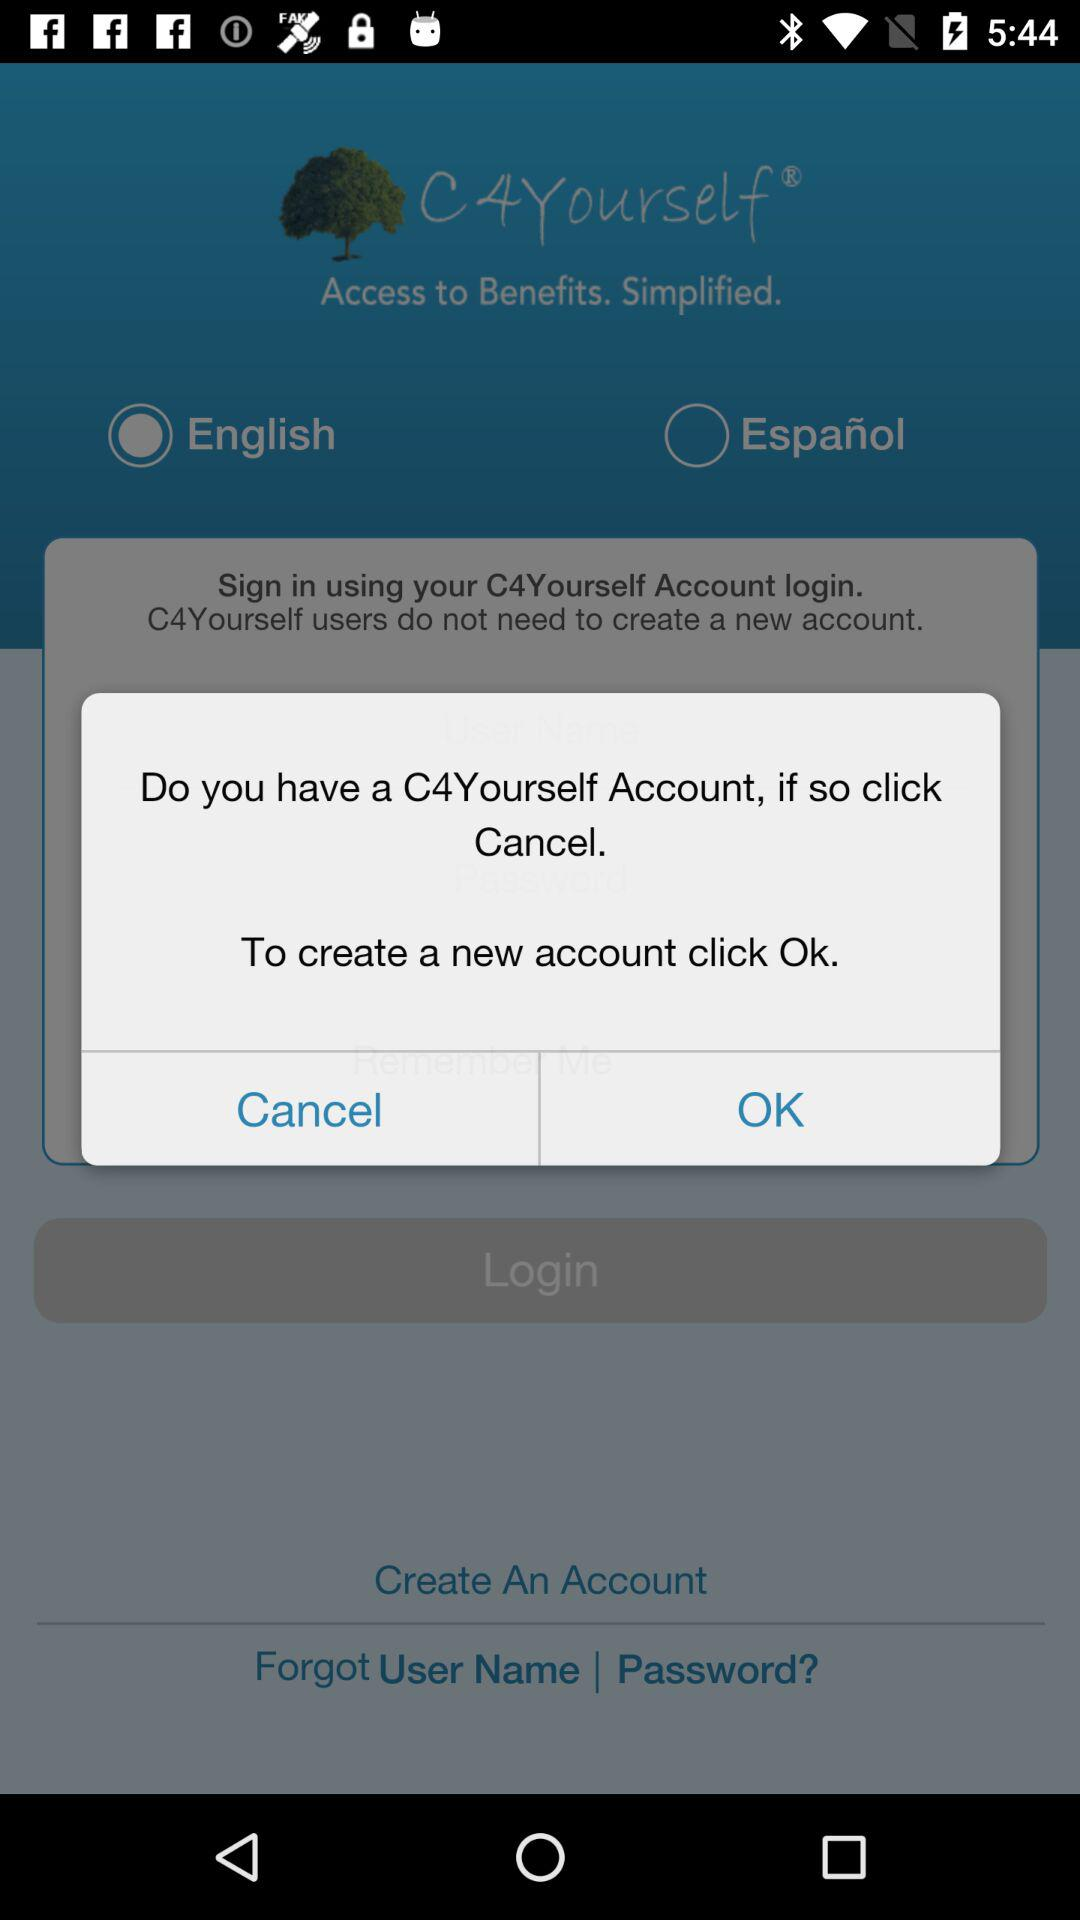Which language is selected? The selected language is English. 